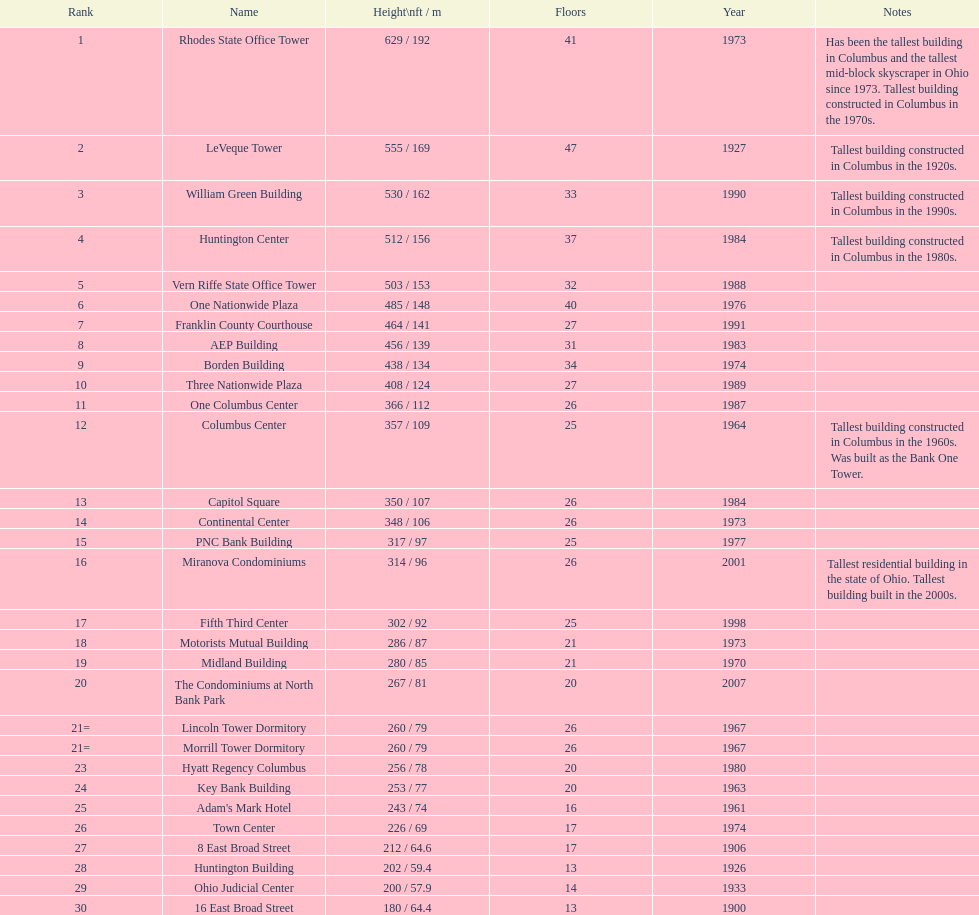How many levels does the capitol square possess? 26. 